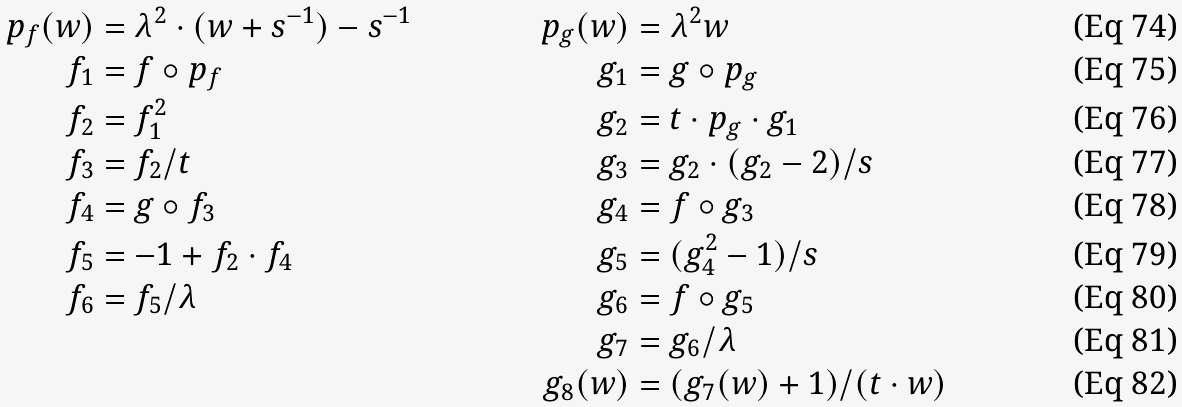<formula> <loc_0><loc_0><loc_500><loc_500>p _ { f } ( w ) & = \lambda ^ { 2 } \cdot ( w + s ^ { - 1 } ) - s ^ { - 1 } & p _ { g } ( w ) & = \lambda ^ { 2 } w \\ f _ { 1 } & = f \circ p _ { f } & g _ { 1 } & = g \circ p _ { g } \\ f _ { 2 } & = f _ { 1 } ^ { 2 } & g _ { 2 } & = t \cdot p _ { g } \cdot g _ { 1 } \\ f _ { 3 } & = f _ { 2 } / t & g _ { 3 } & = g _ { 2 } \cdot ( g _ { 2 } - 2 ) / s \\ f _ { 4 } & = g \circ f _ { 3 } & g _ { 4 } & = f \circ g _ { 3 } \\ f _ { 5 } & = - 1 + f _ { 2 } \cdot f _ { 4 } & g _ { 5 } & = ( g _ { 4 } ^ { 2 } - 1 ) / s \\ f _ { 6 } & = f _ { 5 } / \lambda & g _ { 6 } & = f \circ g _ { 5 } \\ & & g _ { 7 } & = g _ { 6 } / \lambda \\ & & g _ { 8 } ( w ) & = ( g _ { 7 } ( w ) + 1 ) / ( t \cdot w )</formula> 